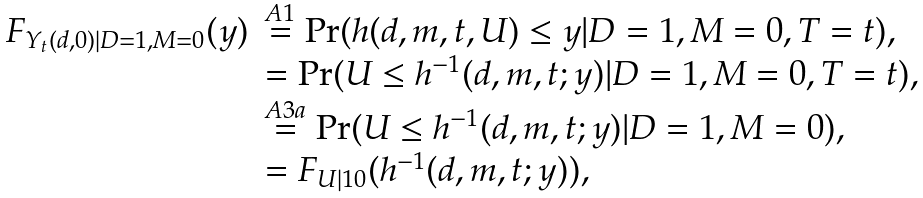<formula> <loc_0><loc_0><loc_500><loc_500>\begin{array} { r l } F _ { Y _ { t } ( d , 0 ) | D = 1 , M = 0 } ( y ) & \stackrel { A 1 } { = } \Pr ( h ( d , m , t , U ) \leq y | D = 1 , M = 0 , T = t ) , \\ & = \Pr ( U \leq h ^ { - 1 } ( d , m , t ; y ) | D = 1 , M = 0 , T = t ) , \\ & \stackrel { A 3 a } { = } \Pr ( U \leq h ^ { - 1 } ( d , m , t ; y ) | D = 1 , M = 0 ) , \\ & = F _ { U | 1 0 } ( h ^ { - 1 } ( d , m , t ; y ) ) , \end{array}</formula> 